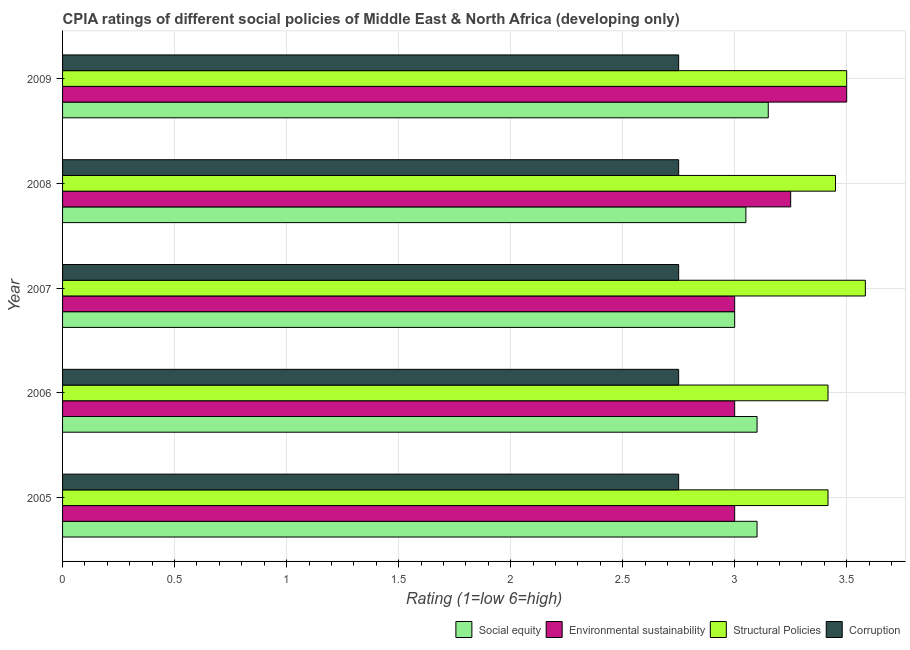How many different coloured bars are there?
Offer a terse response. 4. How many bars are there on the 1st tick from the top?
Make the answer very short. 4. What is the label of the 2nd group of bars from the top?
Keep it short and to the point. 2008. In how many cases, is the number of bars for a given year not equal to the number of legend labels?
Ensure brevity in your answer.  0. What is the cpia rating of structural policies in 2009?
Make the answer very short. 3.5. Across all years, what is the maximum cpia rating of social equity?
Your response must be concise. 3.15. In which year was the cpia rating of environmental sustainability minimum?
Give a very brief answer. 2005. What is the total cpia rating of environmental sustainability in the graph?
Your response must be concise. 15.75. What is the difference between the cpia rating of environmental sustainability in 2006 and that in 2008?
Your answer should be very brief. -0.25. What is the average cpia rating of structural policies per year?
Keep it short and to the point. 3.47. In the year 2006, what is the difference between the cpia rating of structural policies and cpia rating of environmental sustainability?
Your answer should be compact. 0.42. What is the ratio of the cpia rating of environmental sustainability in 2006 to that in 2007?
Provide a short and direct response. 1. Is the cpia rating of corruption in 2007 less than that in 2009?
Offer a terse response. No. Is the difference between the cpia rating of social equity in 2005 and 2006 greater than the difference between the cpia rating of structural policies in 2005 and 2006?
Offer a terse response. No. What is the difference between the highest and the second highest cpia rating of corruption?
Offer a terse response. 0. Is the sum of the cpia rating of corruption in 2005 and 2009 greater than the maximum cpia rating of social equity across all years?
Your answer should be compact. Yes. Is it the case that in every year, the sum of the cpia rating of social equity and cpia rating of corruption is greater than the sum of cpia rating of environmental sustainability and cpia rating of structural policies?
Provide a short and direct response. No. What does the 1st bar from the top in 2009 represents?
Your answer should be very brief. Corruption. What does the 3rd bar from the bottom in 2006 represents?
Make the answer very short. Structural Policies. Is it the case that in every year, the sum of the cpia rating of social equity and cpia rating of environmental sustainability is greater than the cpia rating of structural policies?
Offer a very short reply. Yes. Are all the bars in the graph horizontal?
Give a very brief answer. Yes. How many years are there in the graph?
Keep it short and to the point. 5. What is the difference between two consecutive major ticks on the X-axis?
Offer a very short reply. 0.5. Are the values on the major ticks of X-axis written in scientific E-notation?
Your response must be concise. No. Does the graph contain any zero values?
Ensure brevity in your answer.  No. What is the title of the graph?
Offer a terse response. CPIA ratings of different social policies of Middle East & North Africa (developing only). Does "Korea" appear as one of the legend labels in the graph?
Ensure brevity in your answer.  No. What is the label or title of the Y-axis?
Make the answer very short. Year. What is the Rating (1=low 6=high) of Environmental sustainability in 2005?
Make the answer very short. 3. What is the Rating (1=low 6=high) in Structural Policies in 2005?
Offer a terse response. 3.42. What is the Rating (1=low 6=high) in Corruption in 2005?
Offer a very short reply. 2.75. What is the Rating (1=low 6=high) of Social equity in 2006?
Provide a succinct answer. 3.1. What is the Rating (1=low 6=high) of Structural Policies in 2006?
Offer a terse response. 3.42. What is the Rating (1=low 6=high) of Corruption in 2006?
Your response must be concise. 2.75. What is the Rating (1=low 6=high) in Environmental sustainability in 2007?
Provide a succinct answer. 3. What is the Rating (1=low 6=high) in Structural Policies in 2007?
Keep it short and to the point. 3.58. What is the Rating (1=low 6=high) in Corruption in 2007?
Offer a very short reply. 2.75. What is the Rating (1=low 6=high) of Social equity in 2008?
Provide a succinct answer. 3.05. What is the Rating (1=low 6=high) in Environmental sustainability in 2008?
Your response must be concise. 3.25. What is the Rating (1=low 6=high) in Structural Policies in 2008?
Your answer should be compact. 3.45. What is the Rating (1=low 6=high) in Corruption in 2008?
Provide a short and direct response. 2.75. What is the Rating (1=low 6=high) in Social equity in 2009?
Your answer should be compact. 3.15. What is the Rating (1=low 6=high) in Structural Policies in 2009?
Provide a short and direct response. 3.5. What is the Rating (1=low 6=high) in Corruption in 2009?
Give a very brief answer. 2.75. Across all years, what is the maximum Rating (1=low 6=high) of Social equity?
Your answer should be compact. 3.15. Across all years, what is the maximum Rating (1=low 6=high) of Environmental sustainability?
Offer a terse response. 3.5. Across all years, what is the maximum Rating (1=low 6=high) of Structural Policies?
Offer a very short reply. 3.58. Across all years, what is the maximum Rating (1=low 6=high) in Corruption?
Offer a very short reply. 2.75. Across all years, what is the minimum Rating (1=low 6=high) of Social equity?
Your response must be concise. 3. Across all years, what is the minimum Rating (1=low 6=high) in Environmental sustainability?
Keep it short and to the point. 3. Across all years, what is the minimum Rating (1=low 6=high) of Structural Policies?
Provide a succinct answer. 3.42. Across all years, what is the minimum Rating (1=low 6=high) in Corruption?
Offer a terse response. 2.75. What is the total Rating (1=low 6=high) of Social equity in the graph?
Your answer should be compact. 15.4. What is the total Rating (1=low 6=high) in Environmental sustainability in the graph?
Provide a succinct answer. 15.75. What is the total Rating (1=low 6=high) of Structural Policies in the graph?
Your answer should be very brief. 17.37. What is the total Rating (1=low 6=high) in Corruption in the graph?
Your answer should be very brief. 13.75. What is the difference between the Rating (1=low 6=high) in Structural Policies in 2005 and that in 2006?
Offer a very short reply. 0. What is the difference between the Rating (1=low 6=high) of Corruption in 2005 and that in 2006?
Make the answer very short. 0. What is the difference between the Rating (1=low 6=high) in Structural Policies in 2005 and that in 2007?
Your answer should be very brief. -0.17. What is the difference between the Rating (1=low 6=high) of Environmental sustainability in 2005 and that in 2008?
Offer a very short reply. -0.25. What is the difference between the Rating (1=low 6=high) in Structural Policies in 2005 and that in 2008?
Make the answer very short. -0.03. What is the difference between the Rating (1=low 6=high) in Social equity in 2005 and that in 2009?
Your response must be concise. -0.05. What is the difference between the Rating (1=low 6=high) in Structural Policies in 2005 and that in 2009?
Offer a very short reply. -0.08. What is the difference between the Rating (1=low 6=high) of Structural Policies in 2006 and that in 2007?
Offer a terse response. -0.17. What is the difference between the Rating (1=low 6=high) of Corruption in 2006 and that in 2007?
Your answer should be compact. 0. What is the difference between the Rating (1=low 6=high) in Social equity in 2006 and that in 2008?
Make the answer very short. 0.05. What is the difference between the Rating (1=low 6=high) in Environmental sustainability in 2006 and that in 2008?
Offer a terse response. -0.25. What is the difference between the Rating (1=low 6=high) of Structural Policies in 2006 and that in 2008?
Make the answer very short. -0.03. What is the difference between the Rating (1=low 6=high) in Structural Policies in 2006 and that in 2009?
Offer a very short reply. -0.08. What is the difference between the Rating (1=low 6=high) of Social equity in 2007 and that in 2008?
Offer a terse response. -0.05. What is the difference between the Rating (1=low 6=high) of Environmental sustainability in 2007 and that in 2008?
Make the answer very short. -0.25. What is the difference between the Rating (1=low 6=high) of Structural Policies in 2007 and that in 2008?
Provide a short and direct response. 0.13. What is the difference between the Rating (1=low 6=high) in Corruption in 2007 and that in 2008?
Provide a succinct answer. 0. What is the difference between the Rating (1=low 6=high) of Social equity in 2007 and that in 2009?
Make the answer very short. -0.15. What is the difference between the Rating (1=low 6=high) in Structural Policies in 2007 and that in 2009?
Keep it short and to the point. 0.08. What is the difference between the Rating (1=low 6=high) of Corruption in 2007 and that in 2009?
Ensure brevity in your answer.  0. What is the difference between the Rating (1=low 6=high) of Environmental sustainability in 2008 and that in 2009?
Ensure brevity in your answer.  -0.25. What is the difference between the Rating (1=low 6=high) in Corruption in 2008 and that in 2009?
Make the answer very short. 0. What is the difference between the Rating (1=low 6=high) of Social equity in 2005 and the Rating (1=low 6=high) of Environmental sustainability in 2006?
Make the answer very short. 0.1. What is the difference between the Rating (1=low 6=high) of Social equity in 2005 and the Rating (1=low 6=high) of Structural Policies in 2006?
Give a very brief answer. -0.32. What is the difference between the Rating (1=low 6=high) in Environmental sustainability in 2005 and the Rating (1=low 6=high) in Structural Policies in 2006?
Provide a succinct answer. -0.42. What is the difference between the Rating (1=low 6=high) of Social equity in 2005 and the Rating (1=low 6=high) of Structural Policies in 2007?
Your response must be concise. -0.48. What is the difference between the Rating (1=low 6=high) in Environmental sustainability in 2005 and the Rating (1=low 6=high) in Structural Policies in 2007?
Your response must be concise. -0.58. What is the difference between the Rating (1=low 6=high) of Social equity in 2005 and the Rating (1=low 6=high) of Environmental sustainability in 2008?
Your answer should be very brief. -0.15. What is the difference between the Rating (1=low 6=high) in Social equity in 2005 and the Rating (1=low 6=high) in Structural Policies in 2008?
Your response must be concise. -0.35. What is the difference between the Rating (1=low 6=high) in Environmental sustainability in 2005 and the Rating (1=low 6=high) in Structural Policies in 2008?
Provide a succinct answer. -0.45. What is the difference between the Rating (1=low 6=high) in Environmental sustainability in 2005 and the Rating (1=low 6=high) in Corruption in 2008?
Your answer should be compact. 0.25. What is the difference between the Rating (1=low 6=high) in Structural Policies in 2005 and the Rating (1=low 6=high) in Corruption in 2008?
Keep it short and to the point. 0.67. What is the difference between the Rating (1=low 6=high) of Social equity in 2005 and the Rating (1=low 6=high) of Environmental sustainability in 2009?
Your response must be concise. -0.4. What is the difference between the Rating (1=low 6=high) of Social equity in 2005 and the Rating (1=low 6=high) of Structural Policies in 2009?
Give a very brief answer. -0.4. What is the difference between the Rating (1=low 6=high) in Social equity in 2005 and the Rating (1=low 6=high) in Corruption in 2009?
Offer a very short reply. 0.35. What is the difference between the Rating (1=low 6=high) of Environmental sustainability in 2005 and the Rating (1=low 6=high) of Structural Policies in 2009?
Make the answer very short. -0.5. What is the difference between the Rating (1=low 6=high) of Environmental sustainability in 2005 and the Rating (1=low 6=high) of Corruption in 2009?
Offer a very short reply. 0.25. What is the difference between the Rating (1=low 6=high) of Social equity in 2006 and the Rating (1=low 6=high) of Environmental sustainability in 2007?
Your response must be concise. 0.1. What is the difference between the Rating (1=low 6=high) of Social equity in 2006 and the Rating (1=low 6=high) of Structural Policies in 2007?
Ensure brevity in your answer.  -0.48. What is the difference between the Rating (1=low 6=high) in Social equity in 2006 and the Rating (1=low 6=high) in Corruption in 2007?
Make the answer very short. 0.35. What is the difference between the Rating (1=low 6=high) of Environmental sustainability in 2006 and the Rating (1=low 6=high) of Structural Policies in 2007?
Ensure brevity in your answer.  -0.58. What is the difference between the Rating (1=low 6=high) of Environmental sustainability in 2006 and the Rating (1=low 6=high) of Corruption in 2007?
Your response must be concise. 0.25. What is the difference between the Rating (1=low 6=high) of Structural Policies in 2006 and the Rating (1=low 6=high) of Corruption in 2007?
Your answer should be very brief. 0.67. What is the difference between the Rating (1=low 6=high) of Social equity in 2006 and the Rating (1=low 6=high) of Structural Policies in 2008?
Give a very brief answer. -0.35. What is the difference between the Rating (1=low 6=high) of Social equity in 2006 and the Rating (1=low 6=high) of Corruption in 2008?
Give a very brief answer. 0.35. What is the difference between the Rating (1=low 6=high) of Environmental sustainability in 2006 and the Rating (1=low 6=high) of Structural Policies in 2008?
Your response must be concise. -0.45. What is the difference between the Rating (1=low 6=high) of Environmental sustainability in 2006 and the Rating (1=low 6=high) of Corruption in 2008?
Provide a succinct answer. 0.25. What is the difference between the Rating (1=low 6=high) of Structural Policies in 2006 and the Rating (1=low 6=high) of Corruption in 2008?
Your answer should be compact. 0.67. What is the difference between the Rating (1=low 6=high) of Social equity in 2006 and the Rating (1=low 6=high) of Environmental sustainability in 2009?
Offer a terse response. -0.4. What is the difference between the Rating (1=low 6=high) in Social equity in 2006 and the Rating (1=low 6=high) in Structural Policies in 2009?
Provide a succinct answer. -0.4. What is the difference between the Rating (1=low 6=high) of Environmental sustainability in 2006 and the Rating (1=low 6=high) of Structural Policies in 2009?
Your answer should be very brief. -0.5. What is the difference between the Rating (1=low 6=high) of Environmental sustainability in 2006 and the Rating (1=low 6=high) of Corruption in 2009?
Ensure brevity in your answer.  0.25. What is the difference between the Rating (1=low 6=high) of Structural Policies in 2006 and the Rating (1=low 6=high) of Corruption in 2009?
Ensure brevity in your answer.  0.67. What is the difference between the Rating (1=low 6=high) in Social equity in 2007 and the Rating (1=low 6=high) in Environmental sustainability in 2008?
Make the answer very short. -0.25. What is the difference between the Rating (1=low 6=high) in Social equity in 2007 and the Rating (1=low 6=high) in Structural Policies in 2008?
Your answer should be very brief. -0.45. What is the difference between the Rating (1=low 6=high) of Social equity in 2007 and the Rating (1=low 6=high) of Corruption in 2008?
Ensure brevity in your answer.  0.25. What is the difference between the Rating (1=low 6=high) in Environmental sustainability in 2007 and the Rating (1=low 6=high) in Structural Policies in 2008?
Offer a very short reply. -0.45. What is the difference between the Rating (1=low 6=high) in Environmental sustainability in 2007 and the Rating (1=low 6=high) in Corruption in 2008?
Give a very brief answer. 0.25. What is the difference between the Rating (1=low 6=high) in Social equity in 2007 and the Rating (1=low 6=high) in Environmental sustainability in 2009?
Make the answer very short. -0.5. What is the difference between the Rating (1=low 6=high) in Social equity in 2007 and the Rating (1=low 6=high) in Structural Policies in 2009?
Your answer should be compact. -0.5. What is the difference between the Rating (1=low 6=high) of Social equity in 2007 and the Rating (1=low 6=high) of Corruption in 2009?
Give a very brief answer. 0.25. What is the difference between the Rating (1=low 6=high) in Structural Policies in 2007 and the Rating (1=low 6=high) in Corruption in 2009?
Keep it short and to the point. 0.83. What is the difference between the Rating (1=low 6=high) of Social equity in 2008 and the Rating (1=low 6=high) of Environmental sustainability in 2009?
Your answer should be very brief. -0.45. What is the difference between the Rating (1=low 6=high) in Social equity in 2008 and the Rating (1=low 6=high) in Structural Policies in 2009?
Your answer should be very brief. -0.45. What is the difference between the Rating (1=low 6=high) of Environmental sustainability in 2008 and the Rating (1=low 6=high) of Structural Policies in 2009?
Give a very brief answer. -0.25. What is the difference between the Rating (1=low 6=high) of Environmental sustainability in 2008 and the Rating (1=low 6=high) of Corruption in 2009?
Offer a terse response. 0.5. What is the difference between the Rating (1=low 6=high) in Structural Policies in 2008 and the Rating (1=low 6=high) in Corruption in 2009?
Your answer should be compact. 0.7. What is the average Rating (1=low 6=high) of Social equity per year?
Offer a very short reply. 3.08. What is the average Rating (1=low 6=high) in Environmental sustainability per year?
Give a very brief answer. 3.15. What is the average Rating (1=low 6=high) of Structural Policies per year?
Provide a short and direct response. 3.47. What is the average Rating (1=low 6=high) in Corruption per year?
Make the answer very short. 2.75. In the year 2005, what is the difference between the Rating (1=low 6=high) in Social equity and Rating (1=low 6=high) in Structural Policies?
Give a very brief answer. -0.32. In the year 2005, what is the difference between the Rating (1=low 6=high) of Social equity and Rating (1=low 6=high) of Corruption?
Ensure brevity in your answer.  0.35. In the year 2005, what is the difference between the Rating (1=low 6=high) in Environmental sustainability and Rating (1=low 6=high) in Structural Policies?
Give a very brief answer. -0.42. In the year 2005, what is the difference between the Rating (1=low 6=high) in Environmental sustainability and Rating (1=low 6=high) in Corruption?
Give a very brief answer. 0.25. In the year 2006, what is the difference between the Rating (1=low 6=high) in Social equity and Rating (1=low 6=high) in Environmental sustainability?
Offer a very short reply. 0.1. In the year 2006, what is the difference between the Rating (1=low 6=high) in Social equity and Rating (1=low 6=high) in Structural Policies?
Your answer should be compact. -0.32. In the year 2006, what is the difference between the Rating (1=low 6=high) in Social equity and Rating (1=low 6=high) in Corruption?
Provide a short and direct response. 0.35. In the year 2006, what is the difference between the Rating (1=low 6=high) of Environmental sustainability and Rating (1=low 6=high) of Structural Policies?
Provide a succinct answer. -0.42. In the year 2007, what is the difference between the Rating (1=low 6=high) of Social equity and Rating (1=low 6=high) of Environmental sustainability?
Offer a very short reply. 0. In the year 2007, what is the difference between the Rating (1=low 6=high) in Social equity and Rating (1=low 6=high) in Structural Policies?
Your response must be concise. -0.58. In the year 2007, what is the difference between the Rating (1=low 6=high) in Social equity and Rating (1=low 6=high) in Corruption?
Your answer should be very brief. 0.25. In the year 2007, what is the difference between the Rating (1=low 6=high) in Environmental sustainability and Rating (1=low 6=high) in Structural Policies?
Provide a succinct answer. -0.58. In the year 2008, what is the difference between the Rating (1=low 6=high) in Social equity and Rating (1=low 6=high) in Environmental sustainability?
Your answer should be compact. -0.2. In the year 2008, what is the difference between the Rating (1=low 6=high) in Social equity and Rating (1=low 6=high) in Corruption?
Ensure brevity in your answer.  0.3. In the year 2008, what is the difference between the Rating (1=low 6=high) of Environmental sustainability and Rating (1=low 6=high) of Corruption?
Provide a short and direct response. 0.5. In the year 2008, what is the difference between the Rating (1=low 6=high) in Structural Policies and Rating (1=low 6=high) in Corruption?
Offer a very short reply. 0.7. In the year 2009, what is the difference between the Rating (1=low 6=high) of Social equity and Rating (1=low 6=high) of Environmental sustainability?
Keep it short and to the point. -0.35. In the year 2009, what is the difference between the Rating (1=low 6=high) in Social equity and Rating (1=low 6=high) in Structural Policies?
Your response must be concise. -0.35. In the year 2009, what is the difference between the Rating (1=low 6=high) of Environmental sustainability and Rating (1=low 6=high) of Structural Policies?
Your answer should be very brief. 0. In the year 2009, what is the difference between the Rating (1=low 6=high) in Structural Policies and Rating (1=low 6=high) in Corruption?
Offer a very short reply. 0.75. What is the ratio of the Rating (1=low 6=high) of Environmental sustainability in 2005 to that in 2006?
Keep it short and to the point. 1. What is the ratio of the Rating (1=low 6=high) in Structural Policies in 2005 to that in 2006?
Give a very brief answer. 1. What is the ratio of the Rating (1=low 6=high) in Social equity in 2005 to that in 2007?
Your answer should be compact. 1.03. What is the ratio of the Rating (1=low 6=high) of Structural Policies in 2005 to that in 2007?
Offer a very short reply. 0.95. What is the ratio of the Rating (1=low 6=high) of Corruption in 2005 to that in 2007?
Your response must be concise. 1. What is the ratio of the Rating (1=low 6=high) of Social equity in 2005 to that in 2008?
Offer a terse response. 1.02. What is the ratio of the Rating (1=low 6=high) of Structural Policies in 2005 to that in 2008?
Your answer should be very brief. 0.99. What is the ratio of the Rating (1=low 6=high) of Corruption in 2005 to that in 2008?
Keep it short and to the point. 1. What is the ratio of the Rating (1=low 6=high) in Social equity in 2005 to that in 2009?
Make the answer very short. 0.98. What is the ratio of the Rating (1=low 6=high) in Structural Policies in 2005 to that in 2009?
Give a very brief answer. 0.98. What is the ratio of the Rating (1=low 6=high) in Corruption in 2005 to that in 2009?
Make the answer very short. 1. What is the ratio of the Rating (1=low 6=high) in Structural Policies in 2006 to that in 2007?
Provide a succinct answer. 0.95. What is the ratio of the Rating (1=low 6=high) of Corruption in 2006 to that in 2007?
Make the answer very short. 1. What is the ratio of the Rating (1=low 6=high) of Social equity in 2006 to that in 2008?
Your response must be concise. 1.02. What is the ratio of the Rating (1=low 6=high) of Environmental sustainability in 2006 to that in 2008?
Ensure brevity in your answer.  0.92. What is the ratio of the Rating (1=low 6=high) of Structural Policies in 2006 to that in 2008?
Offer a terse response. 0.99. What is the ratio of the Rating (1=low 6=high) of Social equity in 2006 to that in 2009?
Give a very brief answer. 0.98. What is the ratio of the Rating (1=low 6=high) in Structural Policies in 2006 to that in 2009?
Ensure brevity in your answer.  0.98. What is the ratio of the Rating (1=low 6=high) of Social equity in 2007 to that in 2008?
Give a very brief answer. 0.98. What is the ratio of the Rating (1=low 6=high) of Structural Policies in 2007 to that in 2008?
Provide a short and direct response. 1.04. What is the ratio of the Rating (1=low 6=high) in Corruption in 2007 to that in 2008?
Your answer should be compact. 1. What is the ratio of the Rating (1=low 6=high) in Environmental sustainability in 2007 to that in 2009?
Make the answer very short. 0.86. What is the ratio of the Rating (1=low 6=high) of Structural Policies in 2007 to that in 2009?
Give a very brief answer. 1.02. What is the ratio of the Rating (1=low 6=high) of Social equity in 2008 to that in 2009?
Offer a very short reply. 0.97. What is the ratio of the Rating (1=low 6=high) in Environmental sustainability in 2008 to that in 2009?
Your answer should be very brief. 0.93. What is the ratio of the Rating (1=low 6=high) of Structural Policies in 2008 to that in 2009?
Your answer should be compact. 0.99. What is the ratio of the Rating (1=low 6=high) of Corruption in 2008 to that in 2009?
Your answer should be compact. 1. What is the difference between the highest and the second highest Rating (1=low 6=high) of Structural Policies?
Offer a terse response. 0.08. What is the difference between the highest and the second highest Rating (1=low 6=high) in Corruption?
Ensure brevity in your answer.  0. What is the difference between the highest and the lowest Rating (1=low 6=high) of Social equity?
Offer a terse response. 0.15. What is the difference between the highest and the lowest Rating (1=low 6=high) of Structural Policies?
Keep it short and to the point. 0.17. 